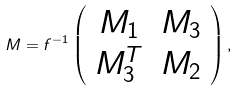Convert formula to latex. <formula><loc_0><loc_0><loc_500><loc_500>M = f ^ { - 1 } \left ( \begin{array} { c r c } M _ { 1 } & M _ { 3 } \\ M _ { 3 } ^ { T } & M _ { 2 } \\ \end{array} \right ) ,</formula> 